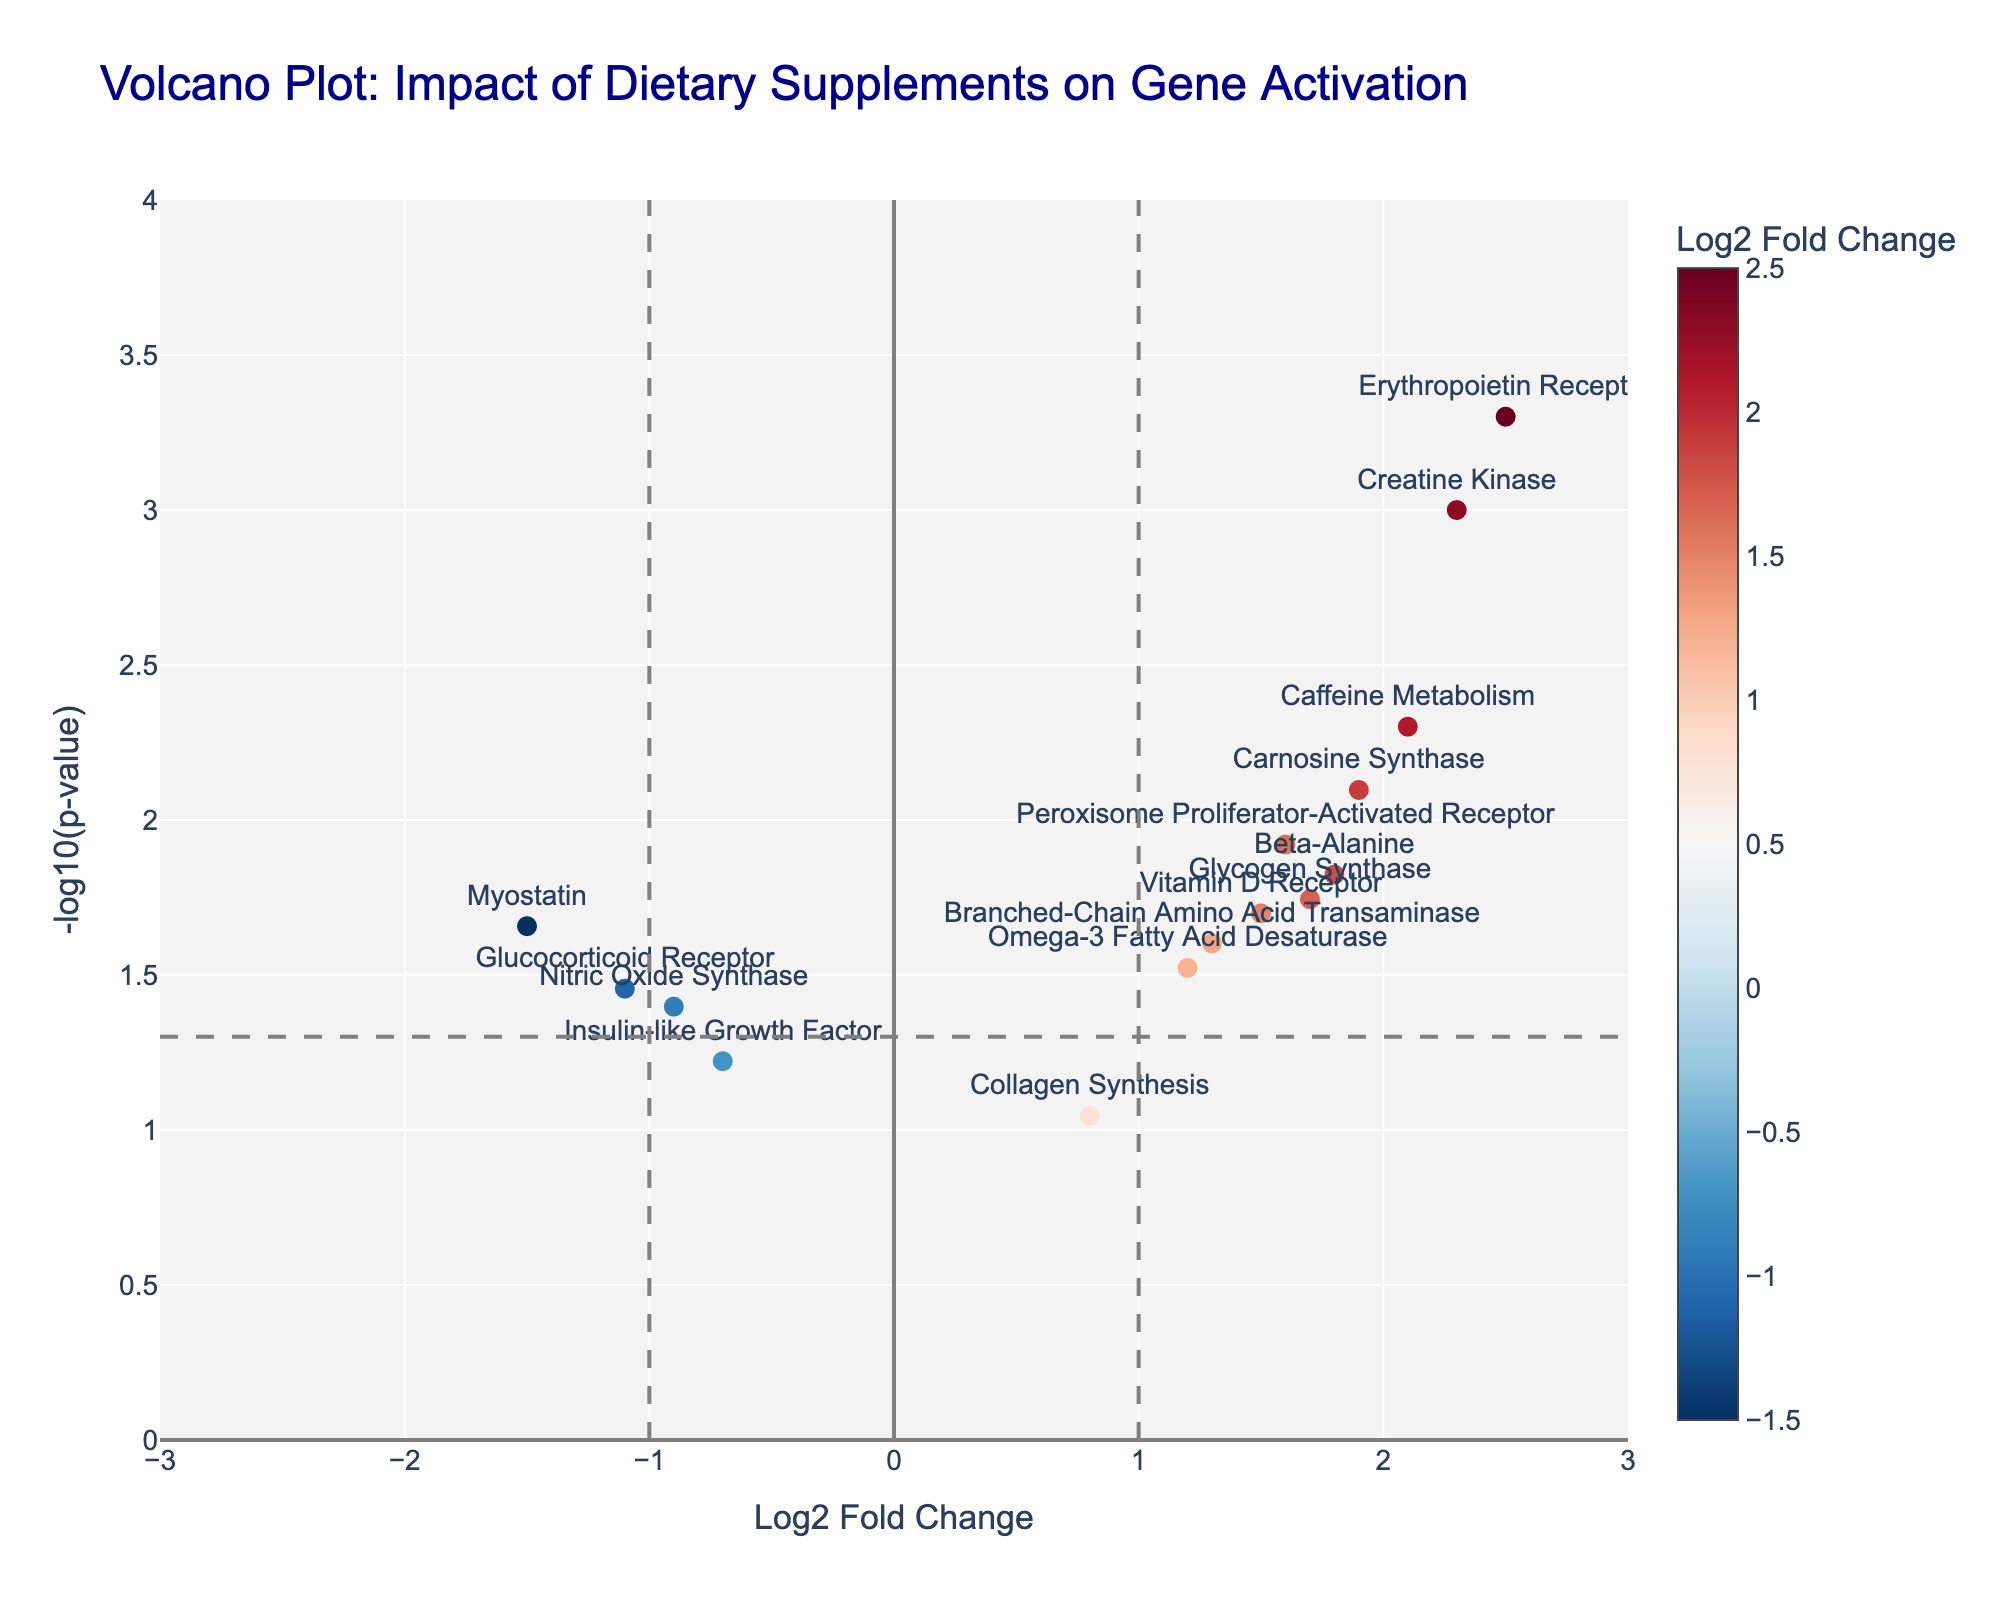What's the title of the figure? The title of the figure is usually displayed at the top of the plot. In this case, it is "Volcano Plot: Impact of Dietary Supplements on Gene Activation".
Answer: Volcano Plot: Impact of Dietary Supplements on Gene Activation What does the x-axis represent? The x-axis represents "Log2 Fold Change", which indicates the logarithmic scale of the fold change in gene expression.
Answer: Log2 Fold Change What does the y-axis represent? The y-axis represents "-log10(p-value)", which is the negative logarithm to base 10 of the p-value.
Answer: -log10(p-value) How many genes have a Log2FoldChange greater than 2? There are two genes with a Log2FoldChange greater than 2: Creatine Kinase and Erythropoietin Receptor. By observing the plot, you can count the points that are located to the right of the vertical threshold line at Log2FoldChange = 2.
Answer: 2 Which gene has the highest -log10(p-value)? By looking at the y-axis and finding the point that is placed at the highest position, we see that the Erythropoietin Receptor has the highest -log10(p-value).
Answer: Erythropoietin Receptor Identify a gene with a negative Log2FoldChange and a -log10(p-value) greater than 1.5. By looking at negative Log2FoldChange on the left side of the plot and checking the y-values greater than 1.5, Myostatin fits this description.
Answer: Myostatin What color scale is used for representing Log2FoldChange? The color scale used for representing Log2FoldChange is a shades of red and blue gradient, with the color bar indicating the values.
Answer: Red to Blue gradient Which has a higher Log2FoldChange: Beta-Alanine or Carnosine Synthase? By comparing the horizontal positions on the plot, Carnosine Synthase (Log2FoldChange = 1.9) has a higher Log2FoldChange than Beta-Alanine (Log2FoldChange = 1.8).
Answer: Carnosine Synthase Are there any genes that have a Log2FoldChange between -1 and 1 and a -log10(p-value) greater than 2? By looking at the area of the plot between -1 and 1 on the x-axis and y greater than 2, there are no points in this region of the plot.
Answer: No Which gene is closest to the threshold line for Log2FoldChange of 1? The gene closest to the vertical threshold line for Log2FoldChange of 1 is Omega-3 Fatty Acid Desaturase.
Answer: Omega-3 Fatty Acid Desaturase 